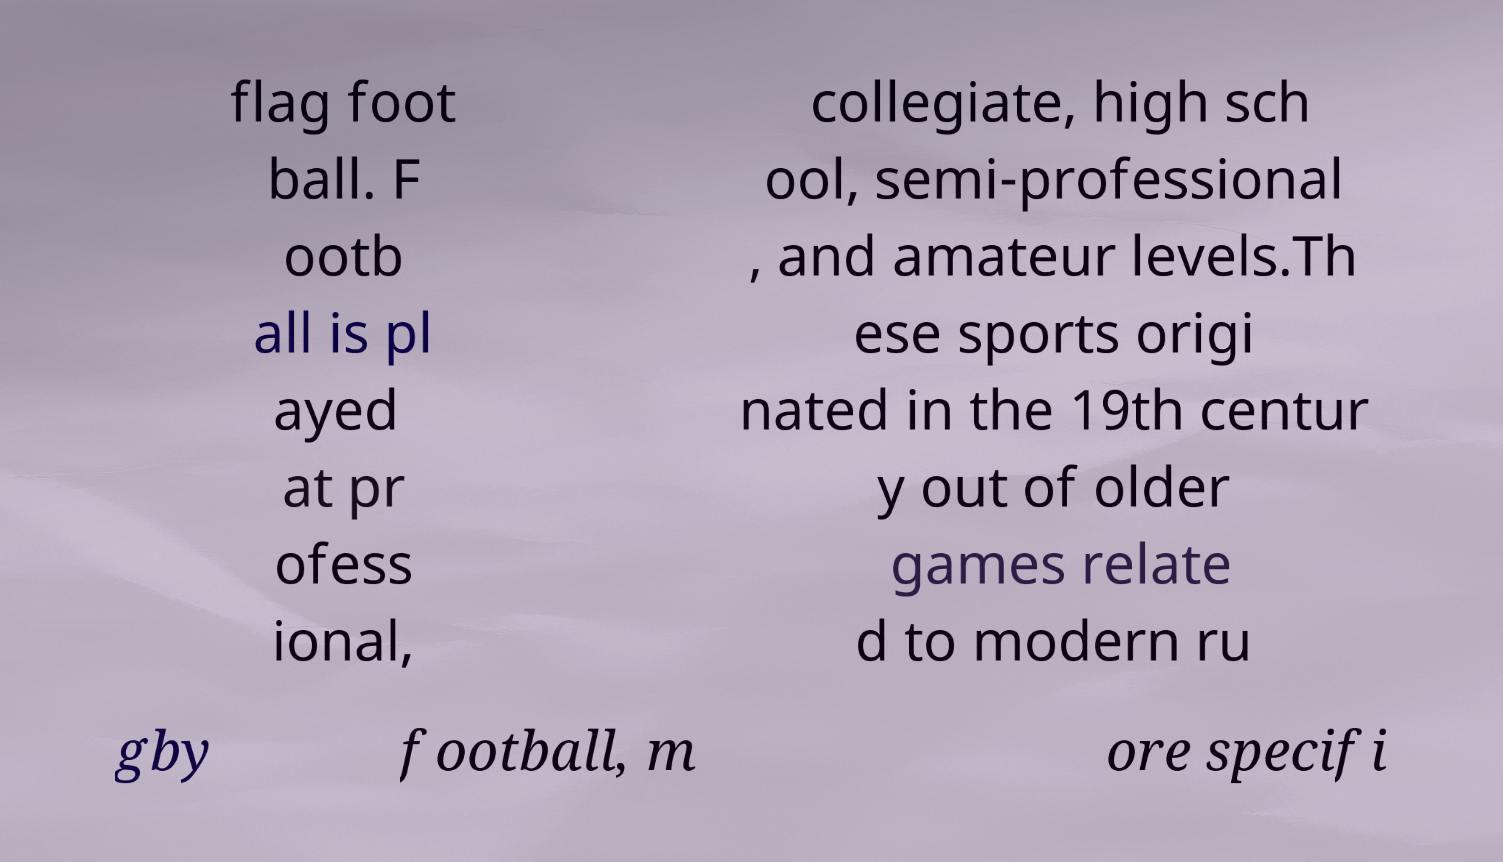I need the written content from this picture converted into text. Can you do that? flag foot ball. F ootb all is pl ayed at pr ofess ional, collegiate, high sch ool, semi-professional , and amateur levels.Th ese sports origi nated in the 19th centur y out of older games relate d to modern ru gby football, m ore specifi 